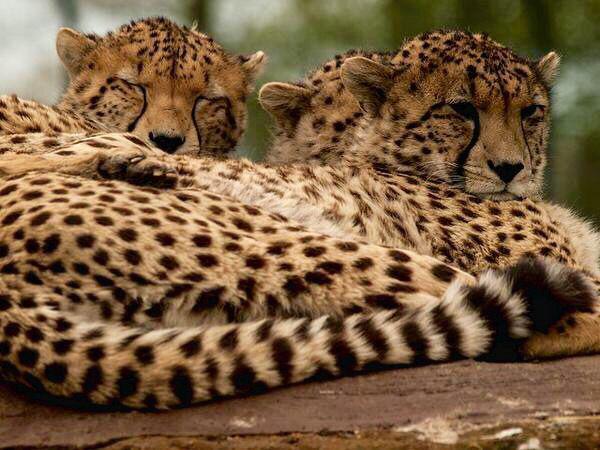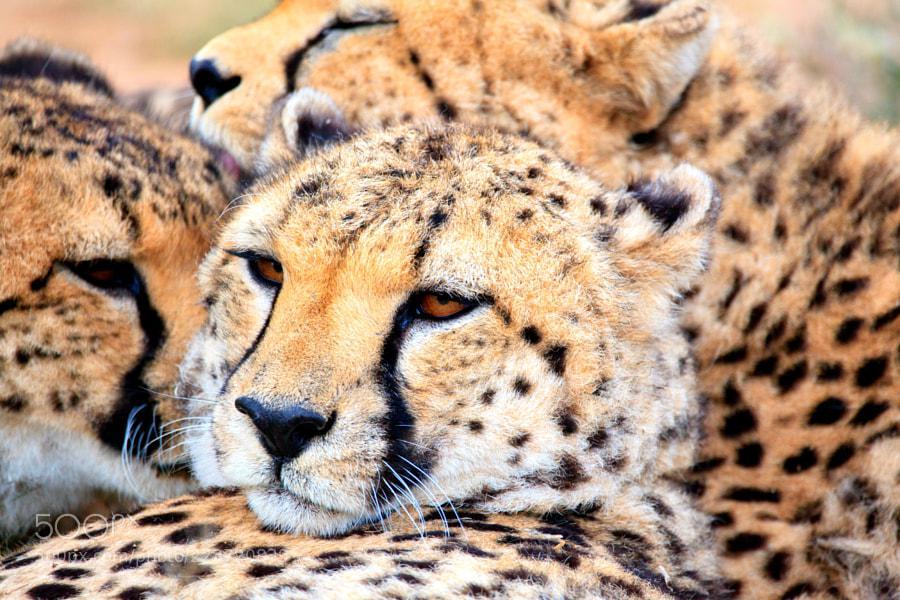The first image is the image on the left, the second image is the image on the right. Assess this claim about the two images: "Three cheetahs rest near a tree.". Correct or not? Answer yes or no. No. The first image is the image on the left, the second image is the image on the right. Considering the images on both sides, is "Each image contains three spotted cats, and at least some of the cats are not reclining." valid? Answer yes or no. No. 